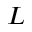<formula> <loc_0><loc_0><loc_500><loc_500>L</formula> 